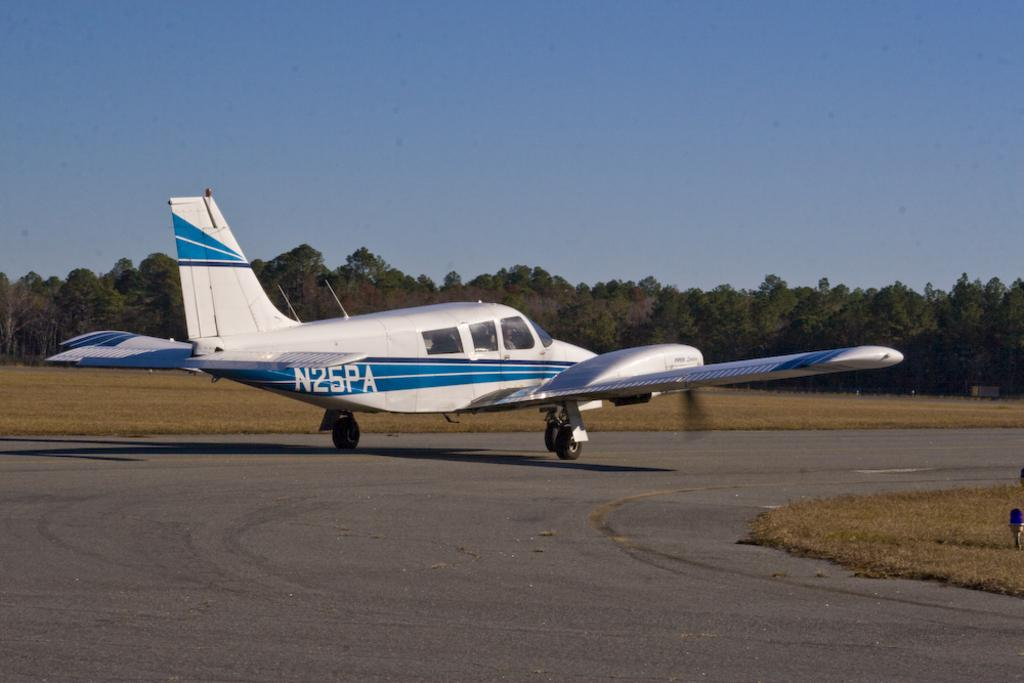<image>
Create a compact narrative representing the image presented. Blue and silver plane getting ready to take off with the plate of N25PA on it's back. 